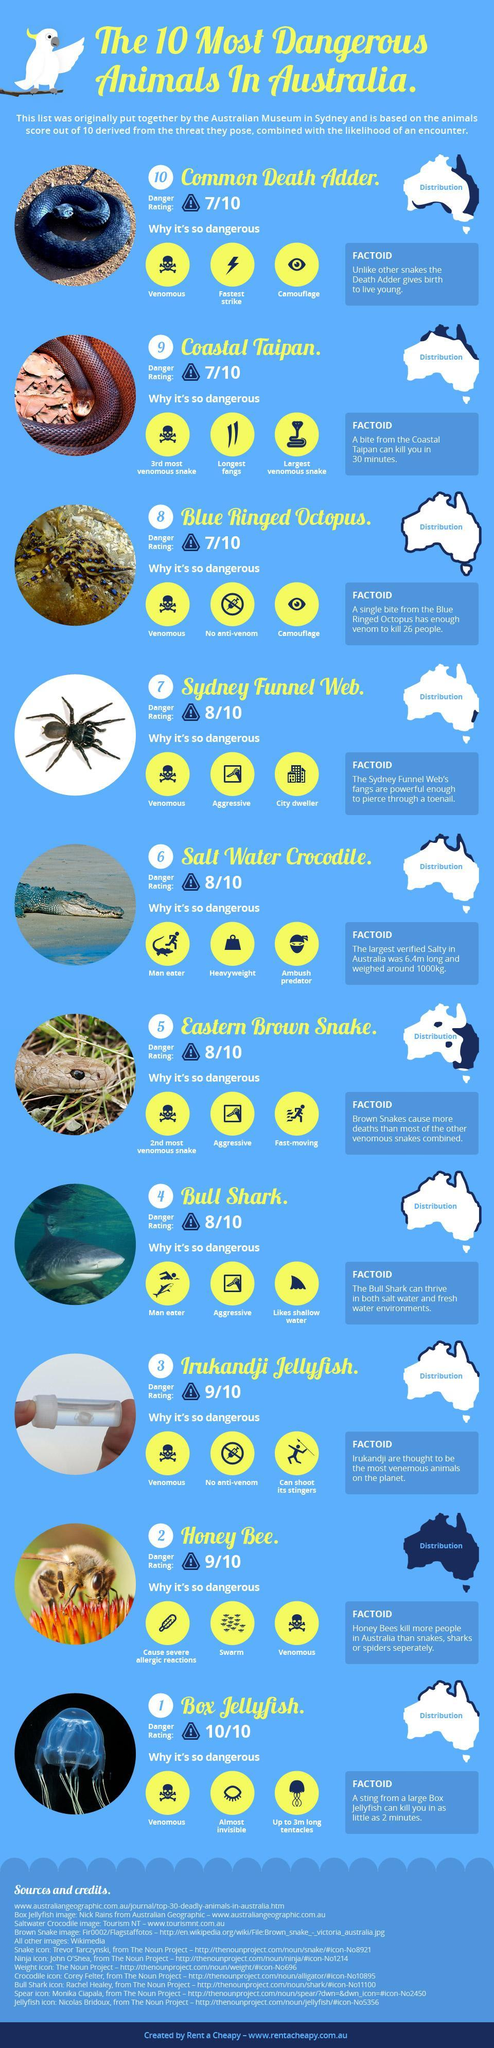Which is the largest venomous snake found in Australia?
Answer the question with a short phrase. Coastal Taipan Which is the second most venomous snake found in Australia? Eastern Brown Snake. Which is the man-eater reptile found in Australia? Salt Water Crocodile. 